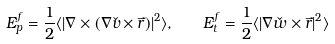<formula> <loc_0><loc_0><loc_500><loc_500>E _ { p } ^ { f } = \frac { 1 } { 2 } \langle | \nabla \times ( \nabla \check { v } \times \vec { r } ) | ^ { 2 } \rangle , \quad E _ { t } ^ { f } = \frac { 1 } { 2 } \langle | \nabla \check { w } \times \vec { r } | ^ { 2 } \rangle</formula> 